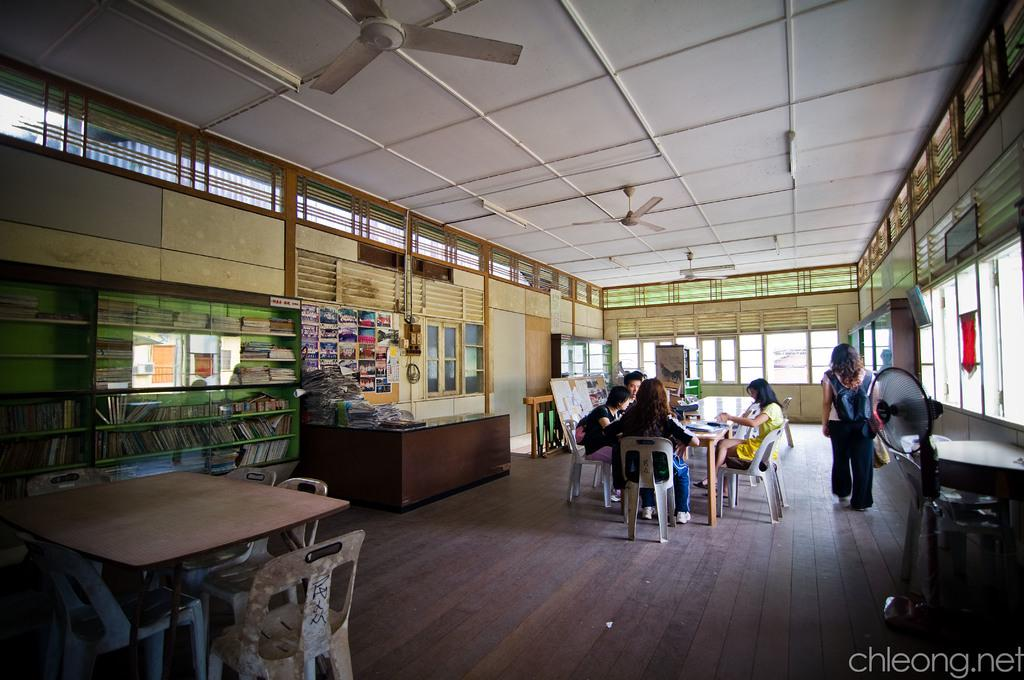What are the people in the image doing? The people in the image are sitting on chairs. Can you describe the woman in the image? There is a woman standing in the image. What type of nerve is visible in the image? There is no nerve present in the image. What type of fruit is the woman holding in the image? The image does not show the woman holding any fruit, including a banana. 